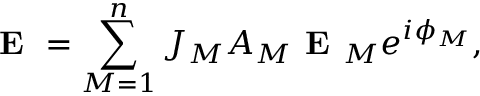Convert formula to latex. <formula><loc_0><loc_0><loc_500><loc_500>E = \sum _ { M = 1 } ^ { n } J _ { M } A _ { M } E _ { M } e ^ { i { \phi } _ { M } } ,</formula> 